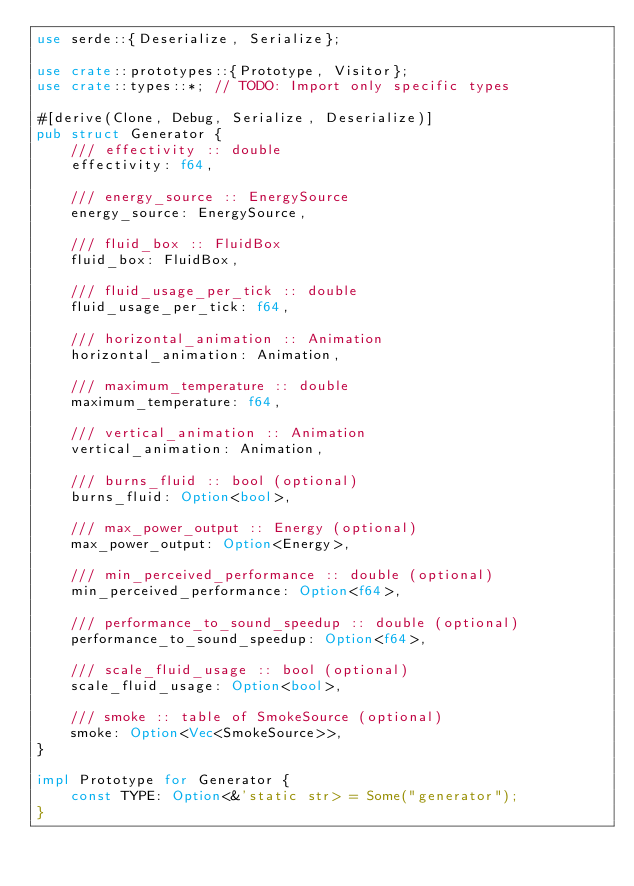Convert code to text. <code><loc_0><loc_0><loc_500><loc_500><_Rust_>use serde::{Deserialize, Serialize};

use crate::prototypes::{Prototype, Visitor};
use crate::types::*; // TODO: Import only specific types

#[derive(Clone, Debug, Serialize, Deserialize)]
pub struct Generator {
    /// effectivity :: double
    effectivity: f64,

    /// energy_source :: EnergySource
    energy_source: EnergySource,

    /// fluid_box :: FluidBox
    fluid_box: FluidBox,

    /// fluid_usage_per_tick :: double
    fluid_usage_per_tick: f64,

    /// horizontal_animation :: Animation
    horizontal_animation: Animation,

    /// maximum_temperature :: double
    maximum_temperature: f64,

    /// vertical_animation :: Animation
    vertical_animation: Animation,

    /// burns_fluid :: bool (optional)
    burns_fluid: Option<bool>,

    /// max_power_output :: Energy (optional)
    max_power_output: Option<Energy>,

    /// min_perceived_performance :: double (optional)
    min_perceived_performance: Option<f64>,

    /// performance_to_sound_speedup :: double (optional)
    performance_to_sound_speedup: Option<f64>,

    /// scale_fluid_usage :: bool (optional)
    scale_fluid_usage: Option<bool>,

    /// smoke :: table of SmokeSource (optional)
    smoke: Option<Vec<SmokeSource>>,
}

impl Prototype for Generator {
    const TYPE: Option<&'static str> = Some("generator");
}
</code> 